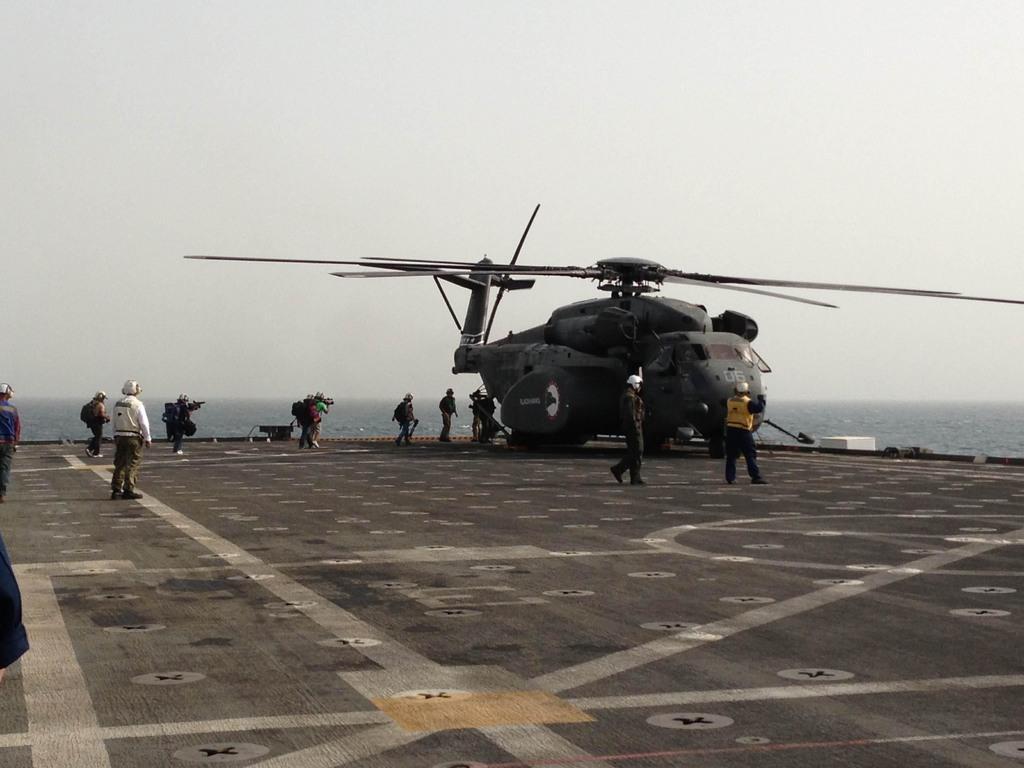Can you describe this image briefly? In this image, this looks like a military helicopter. I can see few people walking and a person standing. This looks like a helicopter runway. I think these are the water. Here is the sky. 